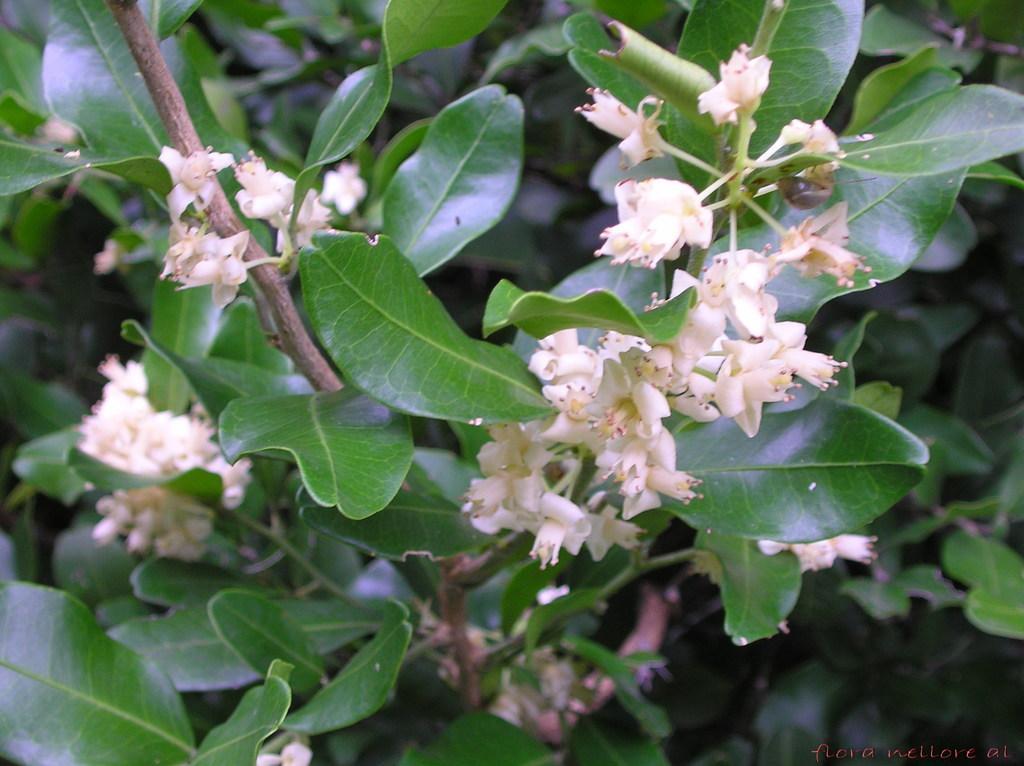In one or two sentences, can you explain what this image depicts? This image consists of flowers, plants and text. This image is taken may be in a garden during a day. 